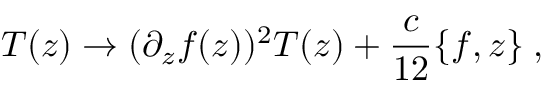<formula> <loc_0><loc_0><loc_500><loc_500>T ( z ) \rightarrow ( \partial _ { z } f ( z ) ) ^ { 2 } T ( z ) + \frac { c } { 1 2 } \{ f , z \} \, ,</formula> 